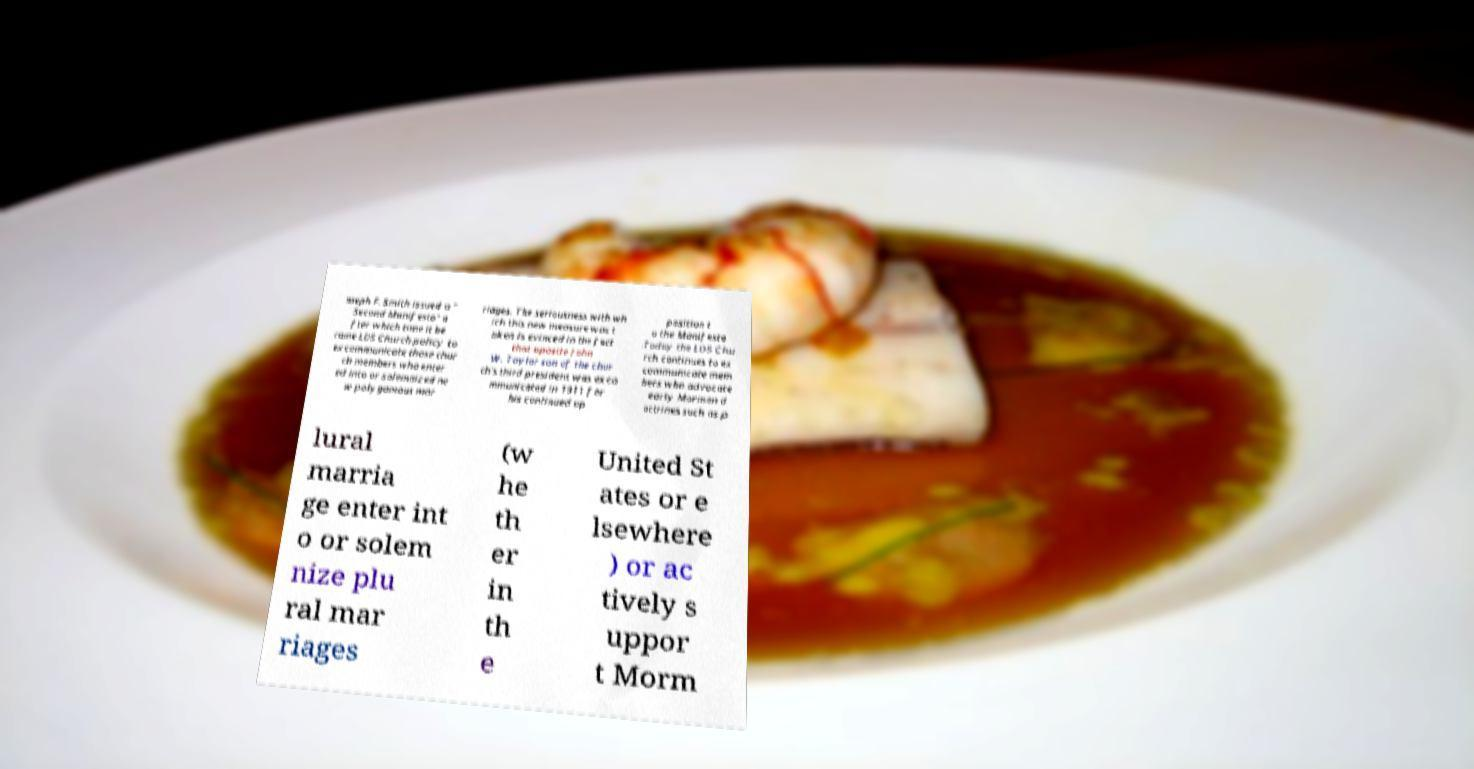Please read and relay the text visible in this image. What does it say? oseph F. Smith issued a " Second Manifesto" a fter which time it be came LDS Church policy to excommunicate those chur ch members who enter ed into or solemnized ne w polygamous mar riages. The seriousness with wh ich this new measure was t aken is evinced in the fact that apostle John W. Taylor son of the chur ch's third president was exco mmunicated in 1911 for his continued op position t o the Manifesto .Today the LDS Chu rch continues to ex communicate mem bers who advocate early Mormon d octrines such as p lural marria ge enter int o or solem nize plu ral mar riages (w he th er in th e United St ates or e lsewhere ) or ac tively s uppor t Morm 